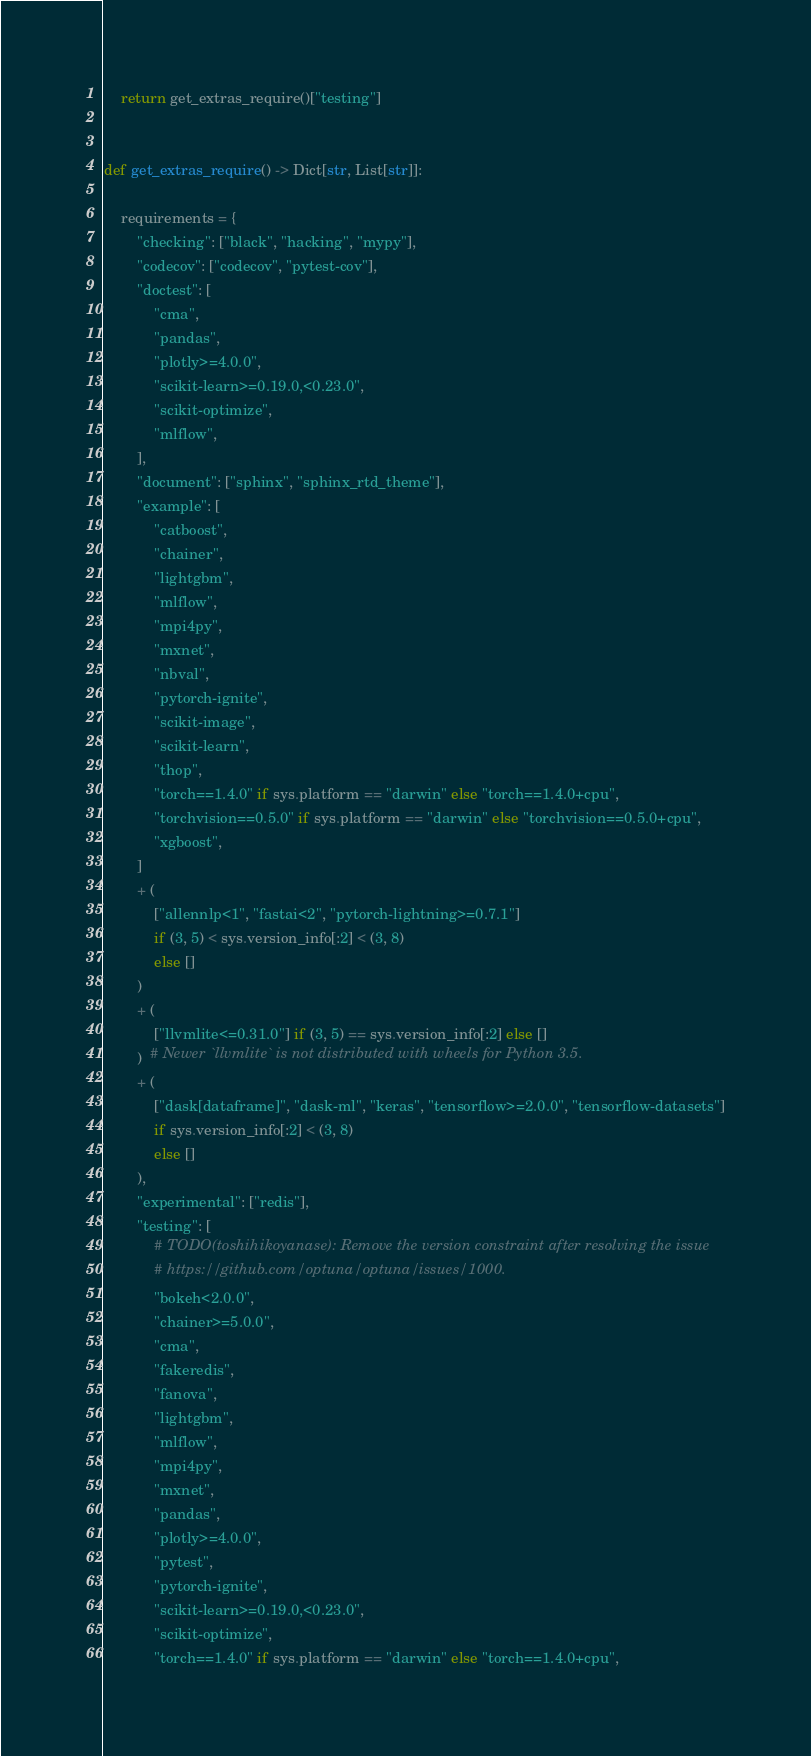<code> <loc_0><loc_0><loc_500><loc_500><_Python_>
    return get_extras_require()["testing"]


def get_extras_require() -> Dict[str, List[str]]:

    requirements = {
        "checking": ["black", "hacking", "mypy"],
        "codecov": ["codecov", "pytest-cov"],
        "doctest": [
            "cma",
            "pandas",
            "plotly>=4.0.0",
            "scikit-learn>=0.19.0,<0.23.0",
            "scikit-optimize",
            "mlflow",
        ],
        "document": ["sphinx", "sphinx_rtd_theme"],
        "example": [
            "catboost",
            "chainer",
            "lightgbm",
            "mlflow",
            "mpi4py",
            "mxnet",
            "nbval",
            "pytorch-ignite",
            "scikit-image",
            "scikit-learn",
            "thop",
            "torch==1.4.0" if sys.platform == "darwin" else "torch==1.4.0+cpu",
            "torchvision==0.5.0" if sys.platform == "darwin" else "torchvision==0.5.0+cpu",
            "xgboost",
        ]
        + (
            ["allennlp<1", "fastai<2", "pytorch-lightning>=0.7.1"]
            if (3, 5) < sys.version_info[:2] < (3, 8)
            else []
        )
        + (
            ["llvmlite<=0.31.0"] if (3, 5) == sys.version_info[:2] else []
        )  # Newer `llvmlite` is not distributed with wheels for Python 3.5.
        + (
            ["dask[dataframe]", "dask-ml", "keras", "tensorflow>=2.0.0", "tensorflow-datasets"]
            if sys.version_info[:2] < (3, 8)
            else []
        ),
        "experimental": ["redis"],
        "testing": [
            # TODO(toshihikoyanase): Remove the version constraint after resolving the issue
            # https://github.com/optuna/optuna/issues/1000.
            "bokeh<2.0.0",
            "chainer>=5.0.0",
            "cma",
            "fakeredis",
            "fanova",
            "lightgbm",
            "mlflow",
            "mpi4py",
            "mxnet",
            "pandas",
            "plotly>=4.0.0",
            "pytest",
            "pytorch-ignite",
            "scikit-learn>=0.19.0,<0.23.0",
            "scikit-optimize",
            "torch==1.4.0" if sys.platform == "darwin" else "torch==1.4.0+cpu",</code> 